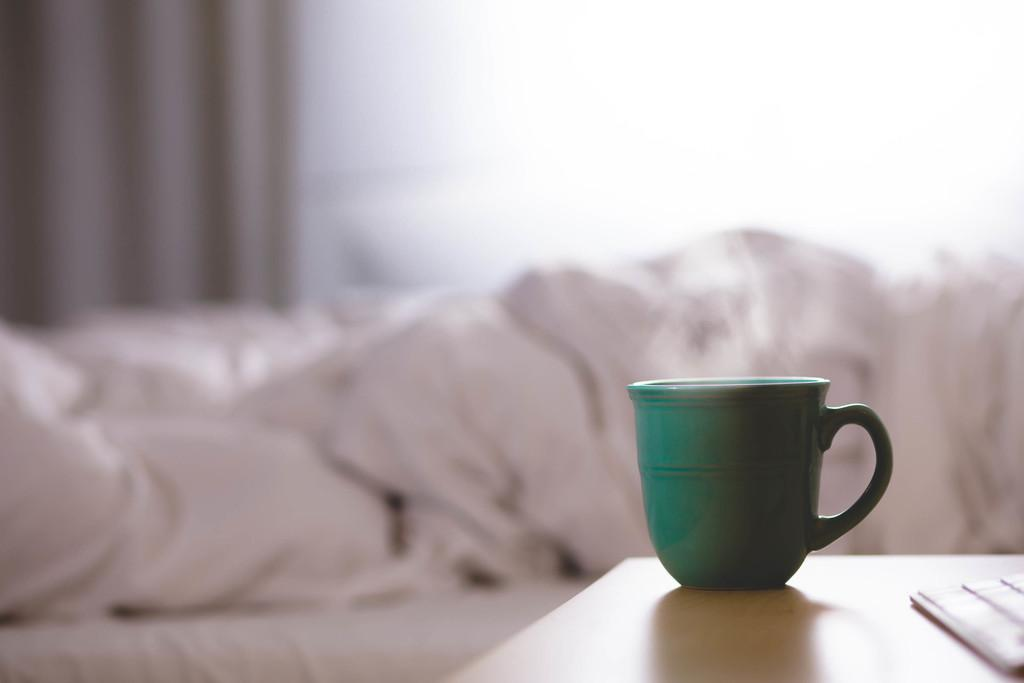What is the setting of the image? The image is inside a room. What can be seen on the table in the image? There is a cup and a keyboard on the table in the image. What type of furniture is visible in the background of the image? There is a white-colored bed in the background of the image. What window treatment is present in the image? There is a curtain associated with the window in the background of the image. Can you see the ocean from the window in the image? There is no ocean visible in the image, as it is set inside a room with a window that overlooks a white-colored bed. What type of bun is being used to hold the keyboard in place on the table? There is no bun present in the image; the keyboard is simply placed on the table. 